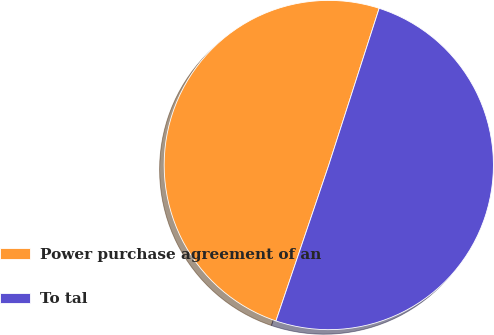Convert chart to OTSL. <chart><loc_0><loc_0><loc_500><loc_500><pie_chart><fcel>Power purchase agreement of an<fcel>To tal<nl><fcel>49.75%<fcel>50.25%<nl></chart> 